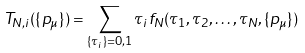<formula> <loc_0><loc_0><loc_500><loc_500>T _ { N , i } ( \{ p _ { \mu } \} ) = \sum _ { \{ \tau _ { i } \} = 0 , 1 } \tau _ { i } f _ { N } ( \tau _ { 1 } , \tau _ { 2 } , \dots , \tau _ { N } , \{ p _ { \mu } \} )</formula> 